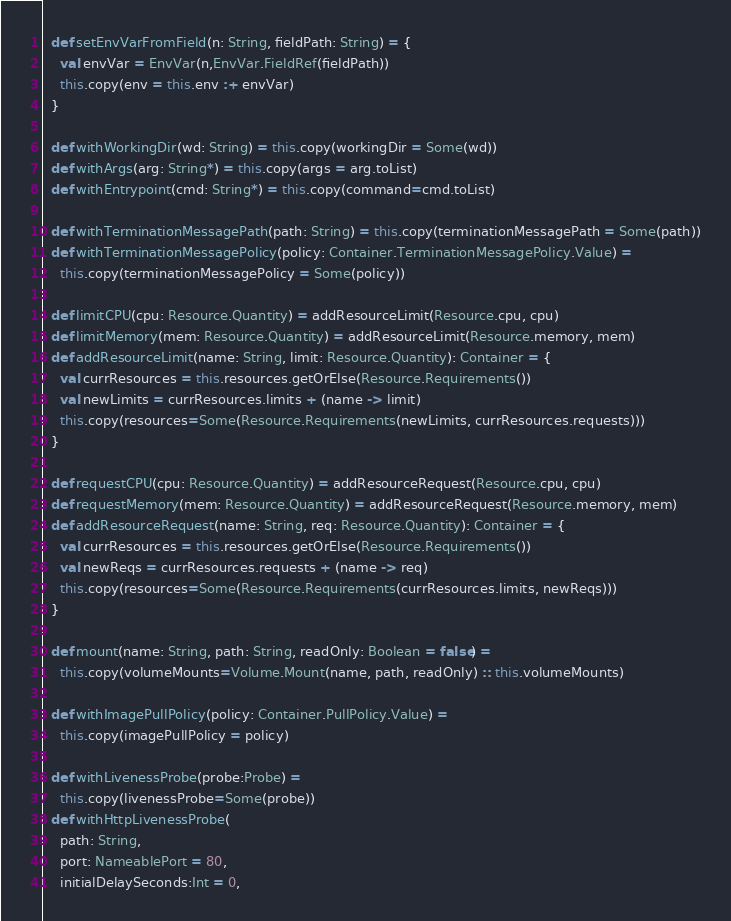<code> <loc_0><loc_0><loc_500><loc_500><_Scala_>  def setEnvVarFromField(n: String, fieldPath: String) = {
    val envVar = EnvVar(n,EnvVar.FieldRef(fieldPath))
    this.copy(env = this.env :+ envVar)
  }

  def withWorkingDir(wd: String) = this.copy(workingDir = Some(wd))
  def withArgs(arg: String*) = this.copy(args = arg.toList)
  def withEntrypoint(cmd: String*) = this.copy(command=cmd.toList)

  def withTerminationMessagePath(path: String) = this.copy(terminationMessagePath = Some(path))
  def withTerminationMessagePolicy(policy: Container.TerminationMessagePolicy.Value) =
    this.copy(terminationMessagePolicy = Some(policy))

  def limitCPU(cpu: Resource.Quantity) = addResourceLimit(Resource.cpu, cpu)
  def limitMemory(mem: Resource.Quantity) = addResourceLimit(Resource.memory, mem)
  def addResourceLimit(name: String, limit: Resource.Quantity): Container = {
    val currResources = this.resources.getOrElse(Resource.Requirements())
    val newLimits = currResources.limits + (name -> limit)
    this.copy(resources=Some(Resource.Requirements(newLimits, currResources.requests)))
  }

  def requestCPU(cpu: Resource.Quantity) = addResourceRequest(Resource.cpu, cpu)
  def requestMemory(mem: Resource.Quantity) = addResourceRequest(Resource.memory, mem)
  def addResourceRequest(name: String, req: Resource.Quantity): Container = {
    val currResources = this.resources.getOrElse(Resource.Requirements())
    val newReqs = currResources.requests + (name -> req)
    this.copy(resources=Some(Resource.Requirements(currResources.limits, newReqs)))
  }

  def mount(name: String, path: String, readOnly: Boolean = false) =
    this.copy(volumeMounts=Volume.Mount(name, path, readOnly) :: this.volumeMounts)

  def withImagePullPolicy(policy: Container.PullPolicy.Value) =
    this.copy(imagePullPolicy = policy)

  def withLivenessProbe(probe:Probe) =
    this.copy(livenessProbe=Some(probe))
  def withHttpLivenessProbe(
    path: String,
    port: NameablePort = 80,
    initialDelaySeconds:Int = 0,</code> 